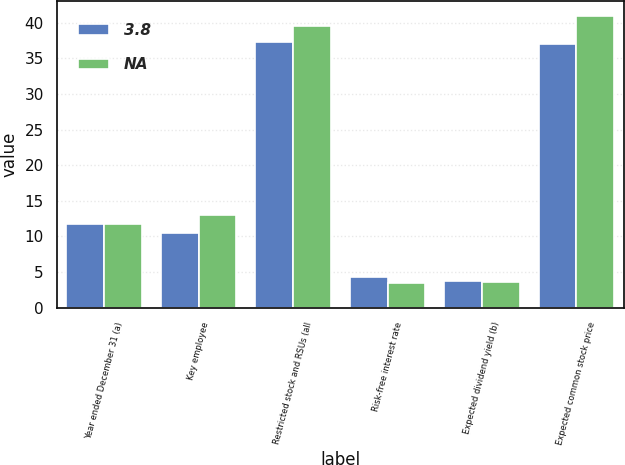<chart> <loc_0><loc_0><loc_500><loc_500><stacked_bar_chart><ecel><fcel>Year ended December 31 (a)<fcel>Key employee<fcel>Restricted stock and RSUs (all<fcel>Risk-free interest rate<fcel>Expected dividend yield (b)<fcel>Expected common stock price<nl><fcel>3.8<fcel>11.74<fcel>10.44<fcel>37.35<fcel>4.25<fcel>3.79<fcel>37<nl><fcel>nan<fcel>11.74<fcel>13.04<fcel>39.58<fcel>3.44<fcel>3.59<fcel>41<nl></chart> 